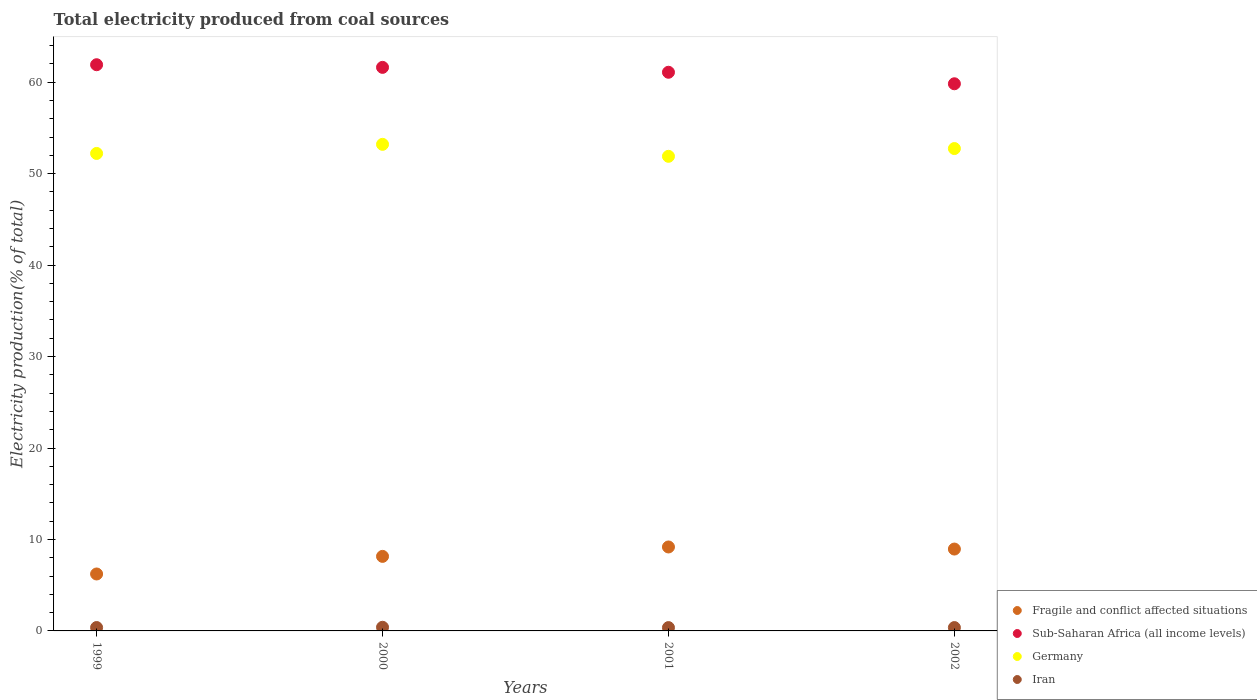How many different coloured dotlines are there?
Offer a terse response. 4. Is the number of dotlines equal to the number of legend labels?
Offer a very short reply. Yes. What is the total electricity produced in Sub-Saharan Africa (all income levels) in 2001?
Ensure brevity in your answer.  61.09. Across all years, what is the maximum total electricity produced in Sub-Saharan Africa (all income levels)?
Give a very brief answer. 61.91. Across all years, what is the minimum total electricity produced in Iran?
Ensure brevity in your answer.  0.36. In which year was the total electricity produced in Iran maximum?
Provide a short and direct response. 2000. In which year was the total electricity produced in Iran minimum?
Keep it short and to the point. 2001. What is the total total electricity produced in Iran in the graph?
Your answer should be very brief. 1.5. What is the difference between the total electricity produced in Germany in 2000 and that in 2001?
Your answer should be very brief. 1.31. What is the difference between the total electricity produced in Iran in 2002 and the total electricity produced in Sub-Saharan Africa (all income levels) in 1999?
Offer a terse response. -61.55. What is the average total electricity produced in Sub-Saharan Africa (all income levels) per year?
Offer a very short reply. 61.11. In the year 1999, what is the difference between the total electricity produced in Germany and total electricity produced in Iran?
Keep it short and to the point. 51.84. What is the ratio of the total electricity produced in Germany in 2000 to that in 2002?
Ensure brevity in your answer.  1.01. Is the total electricity produced in Iran in 1999 less than that in 2001?
Give a very brief answer. No. Is the difference between the total electricity produced in Germany in 1999 and 2000 greater than the difference between the total electricity produced in Iran in 1999 and 2000?
Offer a terse response. No. What is the difference between the highest and the second highest total electricity produced in Germany?
Keep it short and to the point. 0.46. What is the difference between the highest and the lowest total electricity produced in Sub-Saharan Africa (all income levels)?
Provide a short and direct response. 2.08. Is the sum of the total electricity produced in Iran in 1999 and 2000 greater than the maximum total electricity produced in Fragile and conflict affected situations across all years?
Offer a very short reply. No. Is it the case that in every year, the sum of the total electricity produced in Fragile and conflict affected situations and total electricity produced in Sub-Saharan Africa (all income levels)  is greater than the sum of total electricity produced in Germany and total electricity produced in Iran?
Provide a succinct answer. Yes. Is the total electricity produced in Germany strictly less than the total electricity produced in Fragile and conflict affected situations over the years?
Keep it short and to the point. No. How many dotlines are there?
Ensure brevity in your answer.  4. How many years are there in the graph?
Offer a very short reply. 4. What is the difference between two consecutive major ticks on the Y-axis?
Your answer should be compact. 10. Does the graph contain any zero values?
Offer a very short reply. No. Does the graph contain grids?
Keep it short and to the point. No. Where does the legend appear in the graph?
Your answer should be very brief. Bottom right. How many legend labels are there?
Provide a succinct answer. 4. What is the title of the graph?
Offer a terse response. Total electricity produced from coal sources. What is the Electricity production(% of total) in Fragile and conflict affected situations in 1999?
Give a very brief answer. 6.23. What is the Electricity production(% of total) in Sub-Saharan Africa (all income levels) in 1999?
Offer a very short reply. 61.91. What is the Electricity production(% of total) in Germany in 1999?
Ensure brevity in your answer.  52.21. What is the Electricity production(% of total) in Iran in 1999?
Offer a very short reply. 0.37. What is the Electricity production(% of total) of Fragile and conflict affected situations in 2000?
Ensure brevity in your answer.  8.15. What is the Electricity production(% of total) in Sub-Saharan Africa (all income levels) in 2000?
Provide a short and direct response. 61.62. What is the Electricity production(% of total) in Germany in 2000?
Make the answer very short. 53.21. What is the Electricity production(% of total) in Iran in 2000?
Give a very brief answer. 0.4. What is the Electricity production(% of total) of Fragile and conflict affected situations in 2001?
Give a very brief answer. 9.18. What is the Electricity production(% of total) of Sub-Saharan Africa (all income levels) in 2001?
Make the answer very short. 61.09. What is the Electricity production(% of total) in Germany in 2001?
Ensure brevity in your answer.  51.9. What is the Electricity production(% of total) of Iran in 2001?
Provide a succinct answer. 0.36. What is the Electricity production(% of total) in Fragile and conflict affected situations in 2002?
Offer a very short reply. 8.95. What is the Electricity production(% of total) in Sub-Saharan Africa (all income levels) in 2002?
Make the answer very short. 59.83. What is the Electricity production(% of total) of Germany in 2002?
Provide a short and direct response. 52.75. What is the Electricity production(% of total) of Iran in 2002?
Offer a terse response. 0.37. Across all years, what is the maximum Electricity production(% of total) in Fragile and conflict affected situations?
Give a very brief answer. 9.18. Across all years, what is the maximum Electricity production(% of total) in Sub-Saharan Africa (all income levels)?
Your response must be concise. 61.91. Across all years, what is the maximum Electricity production(% of total) of Germany?
Make the answer very short. 53.21. Across all years, what is the maximum Electricity production(% of total) of Iran?
Give a very brief answer. 0.4. Across all years, what is the minimum Electricity production(% of total) of Fragile and conflict affected situations?
Provide a succinct answer. 6.23. Across all years, what is the minimum Electricity production(% of total) in Sub-Saharan Africa (all income levels)?
Provide a short and direct response. 59.83. Across all years, what is the minimum Electricity production(% of total) in Germany?
Provide a short and direct response. 51.9. Across all years, what is the minimum Electricity production(% of total) in Iran?
Provide a succinct answer. 0.36. What is the total Electricity production(% of total) of Fragile and conflict affected situations in the graph?
Provide a short and direct response. 32.51. What is the total Electricity production(% of total) in Sub-Saharan Africa (all income levels) in the graph?
Ensure brevity in your answer.  244.46. What is the total Electricity production(% of total) in Germany in the graph?
Offer a terse response. 210.06. What is the total Electricity production(% of total) of Iran in the graph?
Your answer should be very brief. 1.5. What is the difference between the Electricity production(% of total) of Fragile and conflict affected situations in 1999 and that in 2000?
Your answer should be very brief. -1.93. What is the difference between the Electricity production(% of total) in Sub-Saharan Africa (all income levels) in 1999 and that in 2000?
Provide a succinct answer. 0.29. What is the difference between the Electricity production(% of total) in Germany in 1999 and that in 2000?
Keep it short and to the point. -1. What is the difference between the Electricity production(% of total) in Iran in 1999 and that in 2000?
Provide a short and direct response. -0.03. What is the difference between the Electricity production(% of total) of Fragile and conflict affected situations in 1999 and that in 2001?
Your response must be concise. -2.95. What is the difference between the Electricity production(% of total) of Sub-Saharan Africa (all income levels) in 1999 and that in 2001?
Provide a short and direct response. 0.82. What is the difference between the Electricity production(% of total) of Germany in 1999 and that in 2001?
Make the answer very short. 0.31. What is the difference between the Electricity production(% of total) in Iran in 1999 and that in 2001?
Your answer should be compact. 0.01. What is the difference between the Electricity production(% of total) of Fragile and conflict affected situations in 1999 and that in 2002?
Your answer should be compact. -2.73. What is the difference between the Electricity production(% of total) of Sub-Saharan Africa (all income levels) in 1999 and that in 2002?
Your answer should be very brief. 2.08. What is the difference between the Electricity production(% of total) of Germany in 1999 and that in 2002?
Provide a short and direct response. -0.54. What is the difference between the Electricity production(% of total) of Iran in 1999 and that in 2002?
Your response must be concise. 0. What is the difference between the Electricity production(% of total) of Fragile and conflict affected situations in 2000 and that in 2001?
Provide a succinct answer. -1.03. What is the difference between the Electricity production(% of total) of Sub-Saharan Africa (all income levels) in 2000 and that in 2001?
Your answer should be compact. 0.53. What is the difference between the Electricity production(% of total) in Germany in 2000 and that in 2001?
Your answer should be very brief. 1.31. What is the difference between the Electricity production(% of total) in Iran in 2000 and that in 2001?
Your response must be concise. 0.04. What is the difference between the Electricity production(% of total) in Fragile and conflict affected situations in 2000 and that in 2002?
Provide a succinct answer. -0.8. What is the difference between the Electricity production(% of total) in Sub-Saharan Africa (all income levels) in 2000 and that in 2002?
Your answer should be compact. 1.79. What is the difference between the Electricity production(% of total) of Germany in 2000 and that in 2002?
Your answer should be very brief. 0.46. What is the difference between the Electricity production(% of total) in Iran in 2000 and that in 2002?
Make the answer very short. 0.03. What is the difference between the Electricity production(% of total) of Fragile and conflict affected situations in 2001 and that in 2002?
Provide a succinct answer. 0.23. What is the difference between the Electricity production(% of total) in Sub-Saharan Africa (all income levels) in 2001 and that in 2002?
Provide a short and direct response. 1.26. What is the difference between the Electricity production(% of total) of Germany in 2001 and that in 2002?
Ensure brevity in your answer.  -0.85. What is the difference between the Electricity production(% of total) of Iran in 2001 and that in 2002?
Provide a short and direct response. -0. What is the difference between the Electricity production(% of total) in Fragile and conflict affected situations in 1999 and the Electricity production(% of total) in Sub-Saharan Africa (all income levels) in 2000?
Keep it short and to the point. -55.4. What is the difference between the Electricity production(% of total) in Fragile and conflict affected situations in 1999 and the Electricity production(% of total) in Germany in 2000?
Ensure brevity in your answer.  -46.98. What is the difference between the Electricity production(% of total) in Fragile and conflict affected situations in 1999 and the Electricity production(% of total) in Iran in 2000?
Your answer should be very brief. 5.83. What is the difference between the Electricity production(% of total) in Sub-Saharan Africa (all income levels) in 1999 and the Electricity production(% of total) in Germany in 2000?
Offer a terse response. 8.71. What is the difference between the Electricity production(% of total) in Sub-Saharan Africa (all income levels) in 1999 and the Electricity production(% of total) in Iran in 2000?
Your answer should be very brief. 61.51. What is the difference between the Electricity production(% of total) in Germany in 1999 and the Electricity production(% of total) in Iran in 2000?
Ensure brevity in your answer.  51.81. What is the difference between the Electricity production(% of total) of Fragile and conflict affected situations in 1999 and the Electricity production(% of total) of Sub-Saharan Africa (all income levels) in 2001?
Your response must be concise. -54.86. What is the difference between the Electricity production(% of total) of Fragile and conflict affected situations in 1999 and the Electricity production(% of total) of Germany in 2001?
Your answer should be compact. -45.67. What is the difference between the Electricity production(% of total) in Fragile and conflict affected situations in 1999 and the Electricity production(% of total) in Iran in 2001?
Offer a terse response. 5.86. What is the difference between the Electricity production(% of total) in Sub-Saharan Africa (all income levels) in 1999 and the Electricity production(% of total) in Germany in 2001?
Provide a short and direct response. 10.02. What is the difference between the Electricity production(% of total) in Sub-Saharan Africa (all income levels) in 1999 and the Electricity production(% of total) in Iran in 2001?
Offer a very short reply. 61.55. What is the difference between the Electricity production(% of total) of Germany in 1999 and the Electricity production(% of total) of Iran in 2001?
Provide a short and direct response. 51.85. What is the difference between the Electricity production(% of total) in Fragile and conflict affected situations in 1999 and the Electricity production(% of total) in Sub-Saharan Africa (all income levels) in 2002?
Provide a short and direct response. -53.6. What is the difference between the Electricity production(% of total) of Fragile and conflict affected situations in 1999 and the Electricity production(% of total) of Germany in 2002?
Provide a short and direct response. -46.52. What is the difference between the Electricity production(% of total) of Fragile and conflict affected situations in 1999 and the Electricity production(% of total) of Iran in 2002?
Provide a succinct answer. 5.86. What is the difference between the Electricity production(% of total) in Sub-Saharan Africa (all income levels) in 1999 and the Electricity production(% of total) in Germany in 2002?
Your response must be concise. 9.17. What is the difference between the Electricity production(% of total) in Sub-Saharan Africa (all income levels) in 1999 and the Electricity production(% of total) in Iran in 2002?
Offer a terse response. 61.55. What is the difference between the Electricity production(% of total) in Germany in 1999 and the Electricity production(% of total) in Iran in 2002?
Offer a very short reply. 51.85. What is the difference between the Electricity production(% of total) of Fragile and conflict affected situations in 2000 and the Electricity production(% of total) of Sub-Saharan Africa (all income levels) in 2001?
Offer a very short reply. -52.94. What is the difference between the Electricity production(% of total) in Fragile and conflict affected situations in 2000 and the Electricity production(% of total) in Germany in 2001?
Your answer should be very brief. -43.75. What is the difference between the Electricity production(% of total) of Fragile and conflict affected situations in 2000 and the Electricity production(% of total) of Iran in 2001?
Ensure brevity in your answer.  7.79. What is the difference between the Electricity production(% of total) in Sub-Saharan Africa (all income levels) in 2000 and the Electricity production(% of total) in Germany in 2001?
Give a very brief answer. 9.73. What is the difference between the Electricity production(% of total) of Sub-Saharan Africa (all income levels) in 2000 and the Electricity production(% of total) of Iran in 2001?
Your answer should be very brief. 61.26. What is the difference between the Electricity production(% of total) in Germany in 2000 and the Electricity production(% of total) in Iran in 2001?
Give a very brief answer. 52.84. What is the difference between the Electricity production(% of total) of Fragile and conflict affected situations in 2000 and the Electricity production(% of total) of Sub-Saharan Africa (all income levels) in 2002?
Your response must be concise. -51.68. What is the difference between the Electricity production(% of total) in Fragile and conflict affected situations in 2000 and the Electricity production(% of total) in Germany in 2002?
Your answer should be very brief. -44.6. What is the difference between the Electricity production(% of total) of Fragile and conflict affected situations in 2000 and the Electricity production(% of total) of Iran in 2002?
Ensure brevity in your answer.  7.79. What is the difference between the Electricity production(% of total) of Sub-Saharan Africa (all income levels) in 2000 and the Electricity production(% of total) of Germany in 2002?
Ensure brevity in your answer.  8.88. What is the difference between the Electricity production(% of total) of Sub-Saharan Africa (all income levels) in 2000 and the Electricity production(% of total) of Iran in 2002?
Make the answer very short. 61.26. What is the difference between the Electricity production(% of total) in Germany in 2000 and the Electricity production(% of total) in Iran in 2002?
Your answer should be compact. 52.84. What is the difference between the Electricity production(% of total) of Fragile and conflict affected situations in 2001 and the Electricity production(% of total) of Sub-Saharan Africa (all income levels) in 2002?
Keep it short and to the point. -50.65. What is the difference between the Electricity production(% of total) in Fragile and conflict affected situations in 2001 and the Electricity production(% of total) in Germany in 2002?
Provide a short and direct response. -43.57. What is the difference between the Electricity production(% of total) in Fragile and conflict affected situations in 2001 and the Electricity production(% of total) in Iran in 2002?
Your answer should be compact. 8.81. What is the difference between the Electricity production(% of total) of Sub-Saharan Africa (all income levels) in 2001 and the Electricity production(% of total) of Germany in 2002?
Your answer should be compact. 8.34. What is the difference between the Electricity production(% of total) of Sub-Saharan Africa (all income levels) in 2001 and the Electricity production(% of total) of Iran in 2002?
Make the answer very short. 60.72. What is the difference between the Electricity production(% of total) in Germany in 2001 and the Electricity production(% of total) in Iran in 2002?
Provide a succinct answer. 51.53. What is the average Electricity production(% of total) of Fragile and conflict affected situations per year?
Make the answer very short. 8.13. What is the average Electricity production(% of total) in Sub-Saharan Africa (all income levels) per year?
Provide a succinct answer. 61.11. What is the average Electricity production(% of total) of Germany per year?
Offer a terse response. 52.52. What is the average Electricity production(% of total) in Iran per year?
Your answer should be compact. 0.37. In the year 1999, what is the difference between the Electricity production(% of total) of Fragile and conflict affected situations and Electricity production(% of total) of Sub-Saharan Africa (all income levels)?
Make the answer very short. -55.69. In the year 1999, what is the difference between the Electricity production(% of total) in Fragile and conflict affected situations and Electricity production(% of total) in Germany?
Offer a terse response. -45.99. In the year 1999, what is the difference between the Electricity production(% of total) of Fragile and conflict affected situations and Electricity production(% of total) of Iran?
Make the answer very short. 5.86. In the year 1999, what is the difference between the Electricity production(% of total) in Sub-Saharan Africa (all income levels) and Electricity production(% of total) in Germany?
Offer a terse response. 9.7. In the year 1999, what is the difference between the Electricity production(% of total) of Sub-Saharan Africa (all income levels) and Electricity production(% of total) of Iran?
Your answer should be very brief. 61.54. In the year 1999, what is the difference between the Electricity production(% of total) in Germany and Electricity production(% of total) in Iran?
Offer a very short reply. 51.84. In the year 2000, what is the difference between the Electricity production(% of total) in Fragile and conflict affected situations and Electricity production(% of total) in Sub-Saharan Africa (all income levels)?
Your response must be concise. -53.47. In the year 2000, what is the difference between the Electricity production(% of total) of Fragile and conflict affected situations and Electricity production(% of total) of Germany?
Your answer should be compact. -45.06. In the year 2000, what is the difference between the Electricity production(% of total) in Fragile and conflict affected situations and Electricity production(% of total) in Iran?
Offer a terse response. 7.75. In the year 2000, what is the difference between the Electricity production(% of total) of Sub-Saharan Africa (all income levels) and Electricity production(% of total) of Germany?
Give a very brief answer. 8.42. In the year 2000, what is the difference between the Electricity production(% of total) in Sub-Saharan Africa (all income levels) and Electricity production(% of total) in Iran?
Your response must be concise. 61.23. In the year 2000, what is the difference between the Electricity production(% of total) of Germany and Electricity production(% of total) of Iran?
Give a very brief answer. 52.81. In the year 2001, what is the difference between the Electricity production(% of total) of Fragile and conflict affected situations and Electricity production(% of total) of Sub-Saharan Africa (all income levels)?
Give a very brief answer. -51.91. In the year 2001, what is the difference between the Electricity production(% of total) of Fragile and conflict affected situations and Electricity production(% of total) of Germany?
Give a very brief answer. -42.72. In the year 2001, what is the difference between the Electricity production(% of total) of Fragile and conflict affected situations and Electricity production(% of total) of Iran?
Provide a succinct answer. 8.82. In the year 2001, what is the difference between the Electricity production(% of total) in Sub-Saharan Africa (all income levels) and Electricity production(% of total) in Germany?
Provide a short and direct response. 9.19. In the year 2001, what is the difference between the Electricity production(% of total) in Sub-Saharan Africa (all income levels) and Electricity production(% of total) in Iran?
Provide a short and direct response. 60.73. In the year 2001, what is the difference between the Electricity production(% of total) of Germany and Electricity production(% of total) of Iran?
Offer a very short reply. 51.53. In the year 2002, what is the difference between the Electricity production(% of total) of Fragile and conflict affected situations and Electricity production(% of total) of Sub-Saharan Africa (all income levels)?
Make the answer very short. -50.88. In the year 2002, what is the difference between the Electricity production(% of total) in Fragile and conflict affected situations and Electricity production(% of total) in Germany?
Keep it short and to the point. -43.8. In the year 2002, what is the difference between the Electricity production(% of total) in Fragile and conflict affected situations and Electricity production(% of total) in Iran?
Offer a terse response. 8.59. In the year 2002, what is the difference between the Electricity production(% of total) of Sub-Saharan Africa (all income levels) and Electricity production(% of total) of Germany?
Keep it short and to the point. 7.08. In the year 2002, what is the difference between the Electricity production(% of total) in Sub-Saharan Africa (all income levels) and Electricity production(% of total) in Iran?
Keep it short and to the point. 59.46. In the year 2002, what is the difference between the Electricity production(% of total) of Germany and Electricity production(% of total) of Iran?
Your answer should be very brief. 52.38. What is the ratio of the Electricity production(% of total) of Fragile and conflict affected situations in 1999 to that in 2000?
Provide a short and direct response. 0.76. What is the ratio of the Electricity production(% of total) in Sub-Saharan Africa (all income levels) in 1999 to that in 2000?
Make the answer very short. 1. What is the ratio of the Electricity production(% of total) in Germany in 1999 to that in 2000?
Make the answer very short. 0.98. What is the ratio of the Electricity production(% of total) in Iran in 1999 to that in 2000?
Offer a terse response. 0.93. What is the ratio of the Electricity production(% of total) of Fragile and conflict affected situations in 1999 to that in 2001?
Your response must be concise. 0.68. What is the ratio of the Electricity production(% of total) of Sub-Saharan Africa (all income levels) in 1999 to that in 2001?
Provide a succinct answer. 1.01. What is the ratio of the Electricity production(% of total) in Iran in 1999 to that in 2001?
Offer a terse response. 1.02. What is the ratio of the Electricity production(% of total) in Fragile and conflict affected situations in 1999 to that in 2002?
Provide a short and direct response. 0.7. What is the ratio of the Electricity production(% of total) in Sub-Saharan Africa (all income levels) in 1999 to that in 2002?
Ensure brevity in your answer.  1.03. What is the ratio of the Electricity production(% of total) of Fragile and conflict affected situations in 2000 to that in 2001?
Keep it short and to the point. 0.89. What is the ratio of the Electricity production(% of total) of Sub-Saharan Africa (all income levels) in 2000 to that in 2001?
Keep it short and to the point. 1.01. What is the ratio of the Electricity production(% of total) of Germany in 2000 to that in 2001?
Your answer should be compact. 1.03. What is the ratio of the Electricity production(% of total) of Iran in 2000 to that in 2001?
Give a very brief answer. 1.1. What is the ratio of the Electricity production(% of total) in Fragile and conflict affected situations in 2000 to that in 2002?
Provide a succinct answer. 0.91. What is the ratio of the Electricity production(% of total) in Sub-Saharan Africa (all income levels) in 2000 to that in 2002?
Your response must be concise. 1.03. What is the ratio of the Electricity production(% of total) of Germany in 2000 to that in 2002?
Your response must be concise. 1.01. What is the ratio of the Electricity production(% of total) of Iran in 2000 to that in 2002?
Give a very brief answer. 1.09. What is the ratio of the Electricity production(% of total) of Fragile and conflict affected situations in 2001 to that in 2002?
Your answer should be very brief. 1.03. What is the ratio of the Electricity production(% of total) in Sub-Saharan Africa (all income levels) in 2001 to that in 2002?
Your answer should be compact. 1.02. What is the ratio of the Electricity production(% of total) in Germany in 2001 to that in 2002?
Give a very brief answer. 0.98. What is the difference between the highest and the second highest Electricity production(% of total) in Fragile and conflict affected situations?
Provide a short and direct response. 0.23. What is the difference between the highest and the second highest Electricity production(% of total) in Sub-Saharan Africa (all income levels)?
Provide a short and direct response. 0.29. What is the difference between the highest and the second highest Electricity production(% of total) in Germany?
Your answer should be very brief. 0.46. What is the difference between the highest and the second highest Electricity production(% of total) of Iran?
Your response must be concise. 0.03. What is the difference between the highest and the lowest Electricity production(% of total) of Fragile and conflict affected situations?
Give a very brief answer. 2.95. What is the difference between the highest and the lowest Electricity production(% of total) in Sub-Saharan Africa (all income levels)?
Your answer should be compact. 2.08. What is the difference between the highest and the lowest Electricity production(% of total) of Germany?
Provide a succinct answer. 1.31. What is the difference between the highest and the lowest Electricity production(% of total) in Iran?
Your response must be concise. 0.04. 